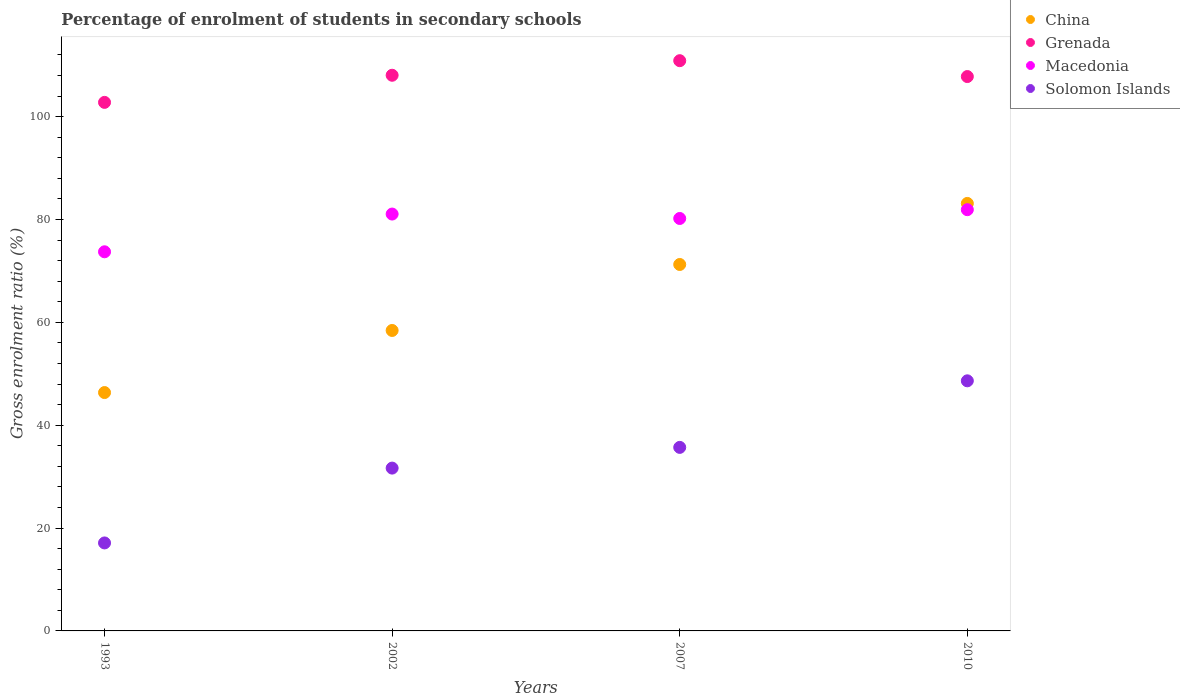How many different coloured dotlines are there?
Provide a succinct answer. 4. What is the percentage of students enrolled in secondary schools in Macedonia in 2002?
Keep it short and to the point. 81.06. Across all years, what is the maximum percentage of students enrolled in secondary schools in Macedonia?
Provide a short and direct response. 81.91. Across all years, what is the minimum percentage of students enrolled in secondary schools in Grenada?
Your answer should be compact. 102.78. In which year was the percentage of students enrolled in secondary schools in Macedonia minimum?
Provide a short and direct response. 1993. What is the total percentage of students enrolled in secondary schools in Solomon Islands in the graph?
Make the answer very short. 133.09. What is the difference between the percentage of students enrolled in secondary schools in Macedonia in 1993 and that in 2007?
Give a very brief answer. -6.48. What is the difference between the percentage of students enrolled in secondary schools in Solomon Islands in 1993 and the percentage of students enrolled in secondary schools in China in 2007?
Make the answer very short. -54.15. What is the average percentage of students enrolled in secondary schools in Macedonia per year?
Give a very brief answer. 79.22. In the year 2002, what is the difference between the percentage of students enrolled in secondary schools in Macedonia and percentage of students enrolled in secondary schools in Solomon Islands?
Offer a very short reply. 49.4. What is the ratio of the percentage of students enrolled in secondary schools in Grenada in 2002 to that in 2007?
Offer a very short reply. 0.97. Is the percentage of students enrolled in secondary schools in China in 1993 less than that in 2002?
Your answer should be very brief. Yes. What is the difference between the highest and the second highest percentage of students enrolled in secondary schools in China?
Keep it short and to the point. 11.87. What is the difference between the highest and the lowest percentage of students enrolled in secondary schools in Solomon Islands?
Ensure brevity in your answer.  31.52. In how many years, is the percentage of students enrolled in secondary schools in Grenada greater than the average percentage of students enrolled in secondary schools in Grenada taken over all years?
Offer a terse response. 3. Is it the case that in every year, the sum of the percentage of students enrolled in secondary schools in Solomon Islands and percentage of students enrolled in secondary schools in China  is greater than the percentage of students enrolled in secondary schools in Macedonia?
Give a very brief answer. No. Is the percentage of students enrolled in secondary schools in Solomon Islands strictly greater than the percentage of students enrolled in secondary schools in Grenada over the years?
Keep it short and to the point. No. Does the graph contain any zero values?
Your answer should be compact. No. Where does the legend appear in the graph?
Give a very brief answer. Top right. What is the title of the graph?
Provide a short and direct response. Percentage of enrolment of students in secondary schools. Does "Korea (Republic)" appear as one of the legend labels in the graph?
Provide a short and direct response. No. What is the label or title of the Y-axis?
Your response must be concise. Gross enrolment ratio (%). What is the Gross enrolment ratio (%) in China in 1993?
Offer a very short reply. 46.35. What is the Gross enrolment ratio (%) of Grenada in 1993?
Offer a very short reply. 102.78. What is the Gross enrolment ratio (%) of Macedonia in 1993?
Ensure brevity in your answer.  73.72. What is the Gross enrolment ratio (%) of Solomon Islands in 1993?
Your response must be concise. 17.11. What is the Gross enrolment ratio (%) of China in 2002?
Offer a very short reply. 58.42. What is the Gross enrolment ratio (%) in Grenada in 2002?
Keep it short and to the point. 108.05. What is the Gross enrolment ratio (%) in Macedonia in 2002?
Your answer should be very brief. 81.06. What is the Gross enrolment ratio (%) of Solomon Islands in 2002?
Your response must be concise. 31.66. What is the Gross enrolment ratio (%) of China in 2007?
Keep it short and to the point. 71.26. What is the Gross enrolment ratio (%) in Grenada in 2007?
Keep it short and to the point. 110.88. What is the Gross enrolment ratio (%) of Macedonia in 2007?
Offer a very short reply. 80.2. What is the Gross enrolment ratio (%) in Solomon Islands in 2007?
Make the answer very short. 35.69. What is the Gross enrolment ratio (%) of China in 2010?
Provide a succinct answer. 83.13. What is the Gross enrolment ratio (%) of Grenada in 2010?
Provide a succinct answer. 107.8. What is the Gross enrolment ratio (%) in Macedonia in 2010?
Offer a terse response. 81.91. What is the Gross enrolment ratio (%) in Solomon Islands in 2010?
Your response must be concise. 48.63. Across all years, what is the maximum Gross enrolment ratio (%) in China?
Your answer should be very brief. 83.13. Across all years, what is the maximum Gross enrolment ratio (%) of Grenada?
Ensure brevity in your answer.  110.88. Across all years, what is the maximum Gross enrolment ratio (%) of Macedonia?
Your answer should be very brief. 81.91. Across all years, what is the maximum Gross enrolment ratio (%) in Solomon Islands?
Offer a very short reply. 48.63. Across all years, what is the minimum Gross enrolment ratio (%) in China?
Your response must be concise. 46.35. Across all years, what is the minimum Gross enrolment ratio (%) of Grenada?
Your answer should be compact. 102.78. Across all years, what is the minimum Gross enrolment ratio (%) in Macedonia?
Your answer should be compact. 73.72. Across all years, what is the minimum Gross enrolment ratio (%) of Solomon Islands?
Offer a very short reply. 17.11. What is the total Gross enrolment ratio (%) in China in the graph?
Give a very brief answer. 259.16. What is the total Gross enrolment ratio (%) in Grenada in the graph?
Make the answer very short. 429.51. What is the total Gross enrolment ratio (%) in Macedonia in the graph?
Offer a very short reply. 316.9. What is the total Gross enrolment ratio (%) of Solomon Islands in the graph?
Keep it short and to the point. 133.09. What is the difference between the Gross enrolment ratio (%) of China in 1993 and that in 2002?
Make the answer very short. -12.07. What is the difference between the Gross enrolment ratio (%) in Grenada in 1993 and that in 2002?
Provide a succinct answer. -5.27. What is the difference between the Gross enrolment ratio (%) in Macedonia in 1993 and that in 2002?
Provide a short and direct response. -7.34. What is the difference between the Gross enrolment ratio (%) of Solomon Islands in 1993 and that in 2002?
Give a very brief answer. -14.55. What is the difference between the Gross enrolment ratio (%) of China in 1993 and that in 2007?
Ensure brevity in your answer.  -24.9. What is the difference between the Gross enrolment ratio (%) in Grenada in 1993 and that in 2007?
Your response must be concise. -8.11. What is the difference between the Gross enrolment ratio (%) of Macedonia in 1993 and that in 2007?
Give a very brief answer. -6.48. What is the difference between the Gross enrolment ratio (%) in Solomon Islands in 1993 and that in 2007?
Offer a very short reply. -18.58. What is the difference between the Gross enrolment ratio (%) in China in 1993 and that in 2010?
Your answer should be very brief. -36.78. What is the difference between the Gross enrolment ratio (%) of Grenada in 1993 and that in 2010?
Give a very brief answer. -5.02. What is the difference between the Gross enrolment ratio (%) in Macedonia in 1993 and that in 2010?
Your response must be concise. -8.19. What is the difference between the Gross enrolment ratio (%) in Solomon Islands in 1993 and that in 2010?
Your response must be concise. -31.52. What is the difference between the Gross enrolment ratio (%) of China in 2002 and that in 2007?
Offer a terse response. -12.83. What is the difference between the Gross enrolment ratio (%) of Grenada in 2002 and that in 2007?
Give a very brief answer. -2.83. What is the difference between the Gross enrolment ratio (%) in Macedonia in 2002 and that in 2007?
Offer a very short reply. 0.86. What is the difference between the Gross enrolment ratio (%) in Solomon Islands in 2002 and that in 2007?
Make the answer very short. -4.03. What is the difference between the Gross enrolment ratio (%) in China in 2002 and that in 2010?
Keep it short and to the point. -24.7. What is the difference between the Gross enrolment ratio (%) in Grenada in 2002 and that in 2010?
Provide a succinct answer. 0.25. What is the difference between the Gross enrolment ratio (%) in Macedonia in 2002 and that in 2010?
Provide a short and direct response. -0.85. What is the difference between the Gross enrolment ratio (%) of Solomon Islands in 2002 and that in 2010?
Provide a succinct answer. -16.97. What is the difference between the Gross enrolment ratio (%) of China in 2007 and that in 2010?
Give a very brief answer. -11.87. What is the difference between the Gross enrolment ratio (%) of Grenada in 2007 and that in 2010?
Offer a very short reply. 3.09. What is the difference between the Gross enrolment ratio (%) in Macedonia in 2007 and that in 2010?
Your response must be concise. -1.71. What is the difference between the Gross enrolment ratio (%) of Solomon Islands in 2007 and that in 2010?
Make the answer very short. -12.94. What is the difference between the Gross enrolment ratio (%) of China in 1993 and the Gross enrolment ratio (%) of Grenada in 2002?
Provide a succinct answer. -61.7. What is the difference between the Gross enrolment ratio (%) of China in 1993 and the Gross enrolment ratio (%) of Macedonia in 2002?
Ensure brevity in your answer.  -34.71. What is the difference between the Gross enrolment ratio (%) in China in 1993 and the Gross enrolment ratio (%) in Solomon Islands in 2002?
Your response must be concise. 14.69. What is the difference between the Gross enrolment ratio (%) of Grenada in 1993 and the Gross enrolment ratio (%) of Macedonia in 2002?
Keep it short and to the point. 21.72. What is the difference between the Gross enrolment ratio (%) in Grenada in 1993 and the Gross enrolment ratio (%) in Solomon Islands in 2002?
Offer a very short reply. 71.12. What is the difference between the Gross enrolment ratio (%) of Macedonia in 1993 and the Gross enrolment ratio (%) of Solomon Islands in 2002?
Ensure brevity in your answer.  42.06. What is the difference between the Gross enrolment ratio (%) of China in 1993 and the Gross enrolment ratio (%) of Grenada in 2007?
Your answer should be very brief. -64.53. What is the difference between the Gross enrolment ratio (%) of China in 1993 and the Gross enrolment ratio (%) of Macedonia in 2007?
Give a very brief answer. -33.85. What is the difference between the Gross enrolment ratio (%) of China in 1993 and the Gross enrolment ratio (%) of Solomon Islands in 2007?
Ensure brevity in your answer.  10.66. What is the difference between the Gross enrolment ratio (%) of Grenada in 1993 and the Gross enrolment ratio (%) of Macedonia in 2007?
Offer a terse response. 22.58. What is the difference between the Gross enrolment ratio (%) in Grenada in 1993 and the Gross enrolment ratio (%) in Solomon Islands in 2007?
Your answer should be very brief. 67.09. What is the difference between the Gross enrolment ratio (%) in Macedonia in 1993 and the Gross enrolment ratio (%) in Solomon Islands in 2007?
Provide a short and direct response. 38.03. What is the difference between the Gross enrolment ratio (%) of China in 1993 and the Gross enrolment ratio (%) of Grenada in 2010?
Your response must be concise. -61.45. What is the difference between the Gross enrolment ratio (%) of China in 1993 and the Gross enrolment ratio (%) of Macedonia in 2010?
Ensure brevity in your answer.  -35.56. What is the difference between the Gross enrolment ratio (%) in China in 1993 and the Gross enrolment ratio (%) in Solomon Islands in 2010?
Provide a short and direct response. -2.28. What is the difference between the Gross enrolment ratio (%) in Grenada in 1993 and the Gross enrolment ratio (%) in Macedonia in 2010?
Your answer should be very brief. 20.87. What is the difference between the Gross enrolment ratio (%) in Grenada in 1993 and the Gross enrolment ratio (%) in Solomon Islands in 2010?
Make the answer very short. 54.15. What is the difference between the Gross enrolment ratio (%) of Macedonia in 1993 and the Gross enrolment ratio (%) of Solomon Islands in 2010?
Your answer should be very brief. 25.09. What is the difference between the Gross enrolment ratio (%) of China in 2002 and the Gross enrolment ratio (%) of Grenada in 2007?
Ensure brevity in your answer.  -52.46. What is the difference between the Gross enrolment ratio (%) of China in 2002 and the Gross enrolment ratio (%) of Macedonia in 2007?
Provide a short and direct response. -21.78. What is the difference between the Gross enrolment ratio (%) of China in 2002 and the Gross enrolment ratio (%) of Solomon Islands in 2007?
Offer a very short reply. 22.73. What is the difference between the Gross enrolment ratio (%) in Grenada in 2002 and the Gross enrolment ratio (%) in Macedonia in 2007?
Give a very brief answer. 27.85. What is the difference between the Gross enrolment ratio (%) of Grenada in 2002 and the Gross enrolment ratio (%) of Solomon Islands in 2007?
Offer a very short reply. 72.36. What is the difference between the Gross enrolment ratio (%) in Macedonia in 2002 and the Gross enrolment ratio (%) in Solomon Islands in 2007?
Your answer should be compact. 45.37. What is the difference between the Gross enrolment ratio (%) of China in 2002 and the Gross enrolment ratio (%) of Grenada in 2010?
Give a very brief answer. -49.37. What is the difference between the Gross enrolment ratio (%) in China in 2002 and the Gross enrolment ratio (%) in Macedonia in 2010?
Give a very brief answer. -23.49. What is the difference between the Gross enrolment ratio (%) of China in 2002 and the Gross enrolment ratio (%) of Solomon Islands in 2010?
Ensure brevity in your answer.  9.79. What is the difference between the Gross enrolment ratio (%) in Grenada in 2002 and the Gross enrolment ratio (%) in Macedonia in 2010?
Your answer should be very brief. 26.14. What is the difference between the Gross enrolment ratio (%) of Grenada in 2002 and the Gross enrolment ratio (%) of Solomon Islands in 2010?
Provide a short and direct response. 59.42. What is the difference between the Gross enrolment ratio (%) in Macedonia in 2002 and the Gross enrolment ratio (%) in Solomon Islands in 2010?
Offer a terse response. 32.43. What is the difference between the Gross enrolment ratio (%) of China in 2007 and the Gross enrolment ratio (%) of Grenada in 2010?
Ensure brevity in your answer.  -36.54. What is the difference between the Gross enrolment ratio (%) in China in 2007 and the Gross enrolment ratio (%) in Macedonia in 2010?
Your response must be concise. -10.66. What is the difference between the Gross enrolment ratio (%) of China in 2007 and the Gross enrolment ratio (%) of Solomon Islands in 2010?
Keep it short and to the point. 22.62. What is the difference between the Gross enrolment ratio (%) in Grenada in 2007 and the Gross enrolment ratio (%) in Macedonia in 2010?
Keep it short and to the point. 28.97. What is the difference between the Gross enrolment ratio (%) of Grenada in 2007 and the Gross enrolment ratio (%) of Solomon Islands in 2010?
Your answer should be compact. 62.25. What is the difference between the Gross enrolment ratio (%) in Macedonia in 2007 and the Gross enrolment ratio (%) in Solomon Islands in 2010?
Offer a very short reply. 31.57. What is the average Gross enrolment ratio (%) in China per year?
Offer a very short reply. 64.79. What is the average Gross enrolment ratio (%) of Grenada per year?
Provide a short and direct response. 107.38. What is the average Gross enrolment ratio (%) in Macedonia per year?
Your response must be concise. 79.22. What is the average Gross enrolment ratio (%) of Solomon Islands per year?
Provide a succinct answer. 33.27. In the year 1993, what is the difference between the Gross enrolment ratio (%) in China and Gross enrolment ratio (%) in Grenada?
Offer a terse response. -56.43. In the year 1993, what is the difference between the Gross enrolment ratio (%) of China and Gross enrolment ratio (%) of Macedonia?
Your answer should be very brief. -27.37. In the year 1993, what is the difference between the Gross enrolment ratio (%) of China and Gross enrolment ratio (%) of Solomon Islands?
Offer a very short reply. 29.24. In the year 1993, what is the difference between the Gross enrolment ratio (%) of Grenada and Gross enrolment ratio (%) of Macedonia?
Offer a very short reply. 29.05. In the year 1993, what is the difference between the Gross enrolment ratio (%) in Grenada and Gross enrolment ratio (%) in Solomon Islands?
Your answer should be compact. 85.67. In the year 1993, what is the difference between the Gross enrolment ratio (%) of Macedonia and Gross enrolment ratio (%) of Solomon Islands?
Ensure brevity in your answer.  56.61. In the year 2002, what is the difference between the Gross enrolment ratio (%) in China and Gross enrolment ratio (%) in Grenada?
Make the answer very short. -49.63. In the year 2002, what is the difference between the Gross enrolment ratio (%) in China and Gross enrolment ratio (%) in Macedonia?
Provide a succinct answer. -22.64. In the year 2002, what is the difference between the Gross enrolment ratio (%) of China and Gross enrolment ratio (%) of Solomon Islands?
Ensure brevity in your answer.  26.76. In the year 2002, what is the difference between the Gross enrolment ratio (%) of Grenada and Gross enrolment ratio (%) of Macedonia?
Offer a terse response. 26.99. In the year 2002, what is the difference between the Gross enrolment ratio (%) in Grenada and Gross enrolment ratio (%) in Solomon Islands?
Offer a terse response. 76.39. In the year 2002, what is the difference between the Gross enrolment ratio (%) in Macedonia and Gross enrolment ratio (%) in Solomon Islands?
Give a very brief answer. 49.4. In the year 2007, what is the difference between the Gross enrolment ratio (%) of China and Gross enrolment ratio (%) of Grenada?
Make the answer very short. -39.63. In the year 2007, what is the difference between the Gross enrolment ratio (%) in China and Gross enrolment ratio (%) in Macedonia?
Your response must be concise. -8.95. In the year 2007, what is the difference between the Gross enrolment ratio (%) in China and Gross enrolment ratio (%) in Solomon Islands?
Make the answer very short. 35.57. In the year 2007, what is the difference between the Gross enrolment ratio (%) of Grenada and Gross enrolment ratio (%) of Macedonia?
Provide a short and direct response. 30.68. In the year 2007, what is the difference between the Gross enrolment ratio (%) in Grenada and Gross enrolment ratio (%) in Solomon Islands?
Keep it short and to the point. 75.19. In the year 2007, what is the difference between the Gross enrolment ratio (%) of Macedonia and Gross enrolment ratio (%) of Solomon Islands?
Give a very brief answer. 44.51. In the year 2010, what is the difference between the Gross enrolment ratio (%) in China and Gross enrolment ratio (%) in Grenada?
Your answer should be compact. -24.67. In the year 2010, what is the difference between the Gross enrolment ratio (%) in China and Gross enrolment ratio (%) in Macedonia?
Offer a terse response. 1.22. In the year 2010, what is the difference between the Gross enrolment ratio (%) in China and Gross enrolment ratio (%) in Solomon Islands?
Your answer should be very brief. 34.5. In the year 2010, what is the difference between the Gross enrolment ratio (%) in Grenada and Gross enrolment ratio (%) in Macedonia?
Provide a succinct answer. 25.89. In the year 2010, what is the difference between the Gross enrolment ratio (%) in Grenada and Gross enrolment ratio (%) in Solomon Islands?
Offer a very short reply. 59.17. In the year 2010, what is the difference between the Gross enrolment ratio (%) of Macedonia and Gross enrolment ratio (%) of Solomon Islands?
Your response must be concise. 33.28. What is the ratio of the Gross enrolment ratio (%) of China in 1993 to that in 2002?
Make the answer very short. 0.79. What is the ratio of the Gross enrolment ratio (%) in Grenada in 1993 to that in 2002?
Offer a terse response. 0.95. What is the ratio of the Gross enrolment ratio (%) in Macedonia in 1993 to that in 2002?
Provide a short and direct response. 0.91. What is the ratio of the Gross enrolment ratio (%) of Solomon Islands in 1993 to that in 2002?
Your response must be concise. 0.54. What is the ratio of the Gross enrolment ratio (%) in China in 1993 to that in 2007?
Make the answer very short. 0.65. What is the ratio of the Gross enrolment ratio (%) in Grenada in 1993 to that in 2007?
Make the answer very short. 0.93. What is the ratio of the Gross enrolment ratio (%) in Macedonia in 1993 to that in 2007?
Your response must be concise. 0.92. What is the ratio of the Gross enrolment ratio (%) in Solomon Islands in 1993 to that in 2007?
Your answer should be very brief. 0.48. What is the ratio of the Gross enrolment ratio (%) of China in 1993 to that in 2010?
Ensure brevity in your answer.  0.56. What is the ratio of the Gross enrolment ratio (%) in Grenada in 1993 to that in 2010?
Ensure brevity in your answer.  0.95. What is the ratio of the Gross enrolment ratio (%) in Macedonia in 1993 to that in 2010?
Give a very brief answer. 0.9. What is the ratio of the Gross enrolment ratio (%) of Solomon Islands in 1993 to that in 2010?
Ensure brevity in your answer.  0.35. What is the ratio of the Gross enrolment ratio (%) in China in 2002 to that in 2007?
Keep it short and to the point. 0.82. What is the ratio of the Gross enrolment ratio (%) of Grenada in 2002 to that in 2007?
Offer a terse response. 0.97. What is the ratio of the Gross enrolment ratio (%) of Macedonia in 2002 to that in 2007?
Keep it short and to the point. 1.01. What is the ratio of the Gross enrolment ratio (%) of Solomon Islands in 2002 to that in 2007?
Offer a terse response. 0.89. What is the ratio of the Gross enrolment ratio (%) in China in 2002 to that in 2010?
Keep it short and to the point. 0.7. What is the ratio of the Gross enrolment ratio (%) in Solomon Islands in 2002 to that in 2010?
Your answer should be very brief. 0.65. What is the ratio of the Gross enrolment ratio (%) of China in 2007 to that in 2010?
Provide a short and direct response. 0.86. What is the ratio of the Gross enrolment ratio (%) of Grenada in 2007 to that in 2010?
Provide a succinct answer. 1.03. What is the ratio of the Gross enrolment ratio (%) of Macedonia in 2007 to that in 2010?
Your response must be concise. 0.98. What is the ratio of the Gross enrolment ratio (%) in Solomon Islands in 2007 to that in 2010?
Provide a short and direct response. 0.73. What is the difference between the highest and the second highest Gross enrolment ratio (%) of China?
Your answer should be compact. 11.87. What is the difference between the highest and the second highest Gross enrolment ratio (%) in Grenada?
Offer a terse response. 2.83. What is the difference between the highest and the second highest Gross enrolment ratio (%) in Macedonia?
Keep it short and to the point. 0.85. What is the difference between the highest and the second highest Gross enrolment ratio (%) of Solomon Islands?
Keep it short and to the point. 12.94. What is the difference between the highest and the lowest Gross enrolment ratio (%) in China?
Provide a succinct answer. 36.78. What is the difference between the highest and the lowest Gross enrolment ratio (%) of Grenada?
Offer a very short reply. 8.11. What is the difference between the highest and the lowest Gross enrolment ratio (%) in Macedonia?
Offer a very short reply. 8.19. What is the difference between the highest and the lowest Gross enrolment ratio (%) of Solomon Islands?
Provide a succinct answer. 31.52. 